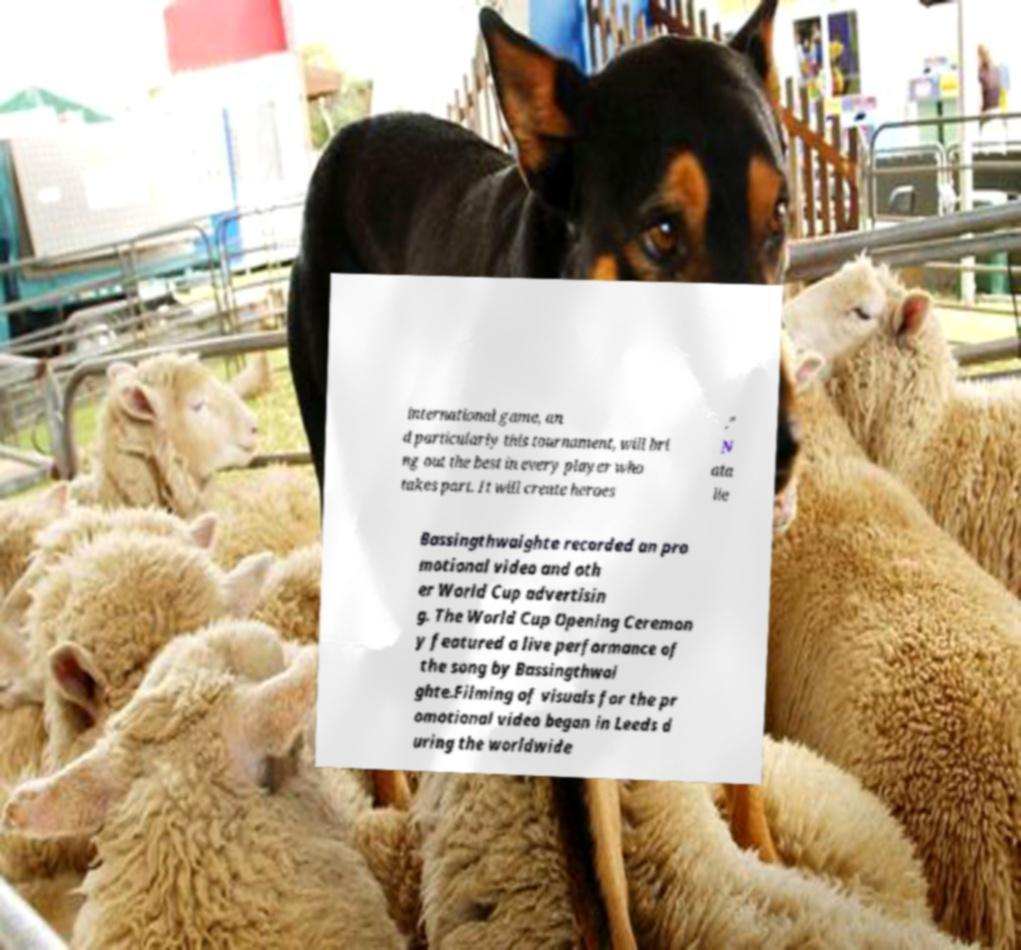For documentation purposes, I need the text within this image transcribed. Could you provide that? international game, an d particularly this tournament, will bri ng out the best in every player who takes part. It will create heroes ." N ata lie Bassingthwaighte recorded an pro motional video and oth er World Cup advertisin g. The World Cup Opening Ceremon y featured a live performance of the song by Bassingthwai ghte.Filming of visuals for the pr omotional video began in Leeds d uring the worldwide 